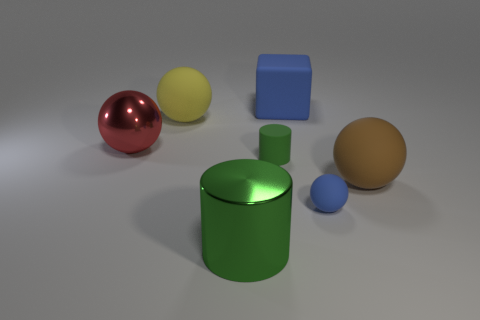There is a blue matte object that is in front of the metallic thing that is behind the metallic thing that is in front of the big shiny ball; how big is it?
Your answer should be compact. Small. How many other objects are the same color as the metallic cylinder?
Make the answer very short. 1. There is a tiny matte thing behind the big brown rubber ball; is it the same color as the shiny cylinder?
Your answer should be compact. Yes. There is a object that is the same color as the big cylinder; what size is it?
Your answer should be compact. Small. What number of things are rubber things that are right of the blue block or objects behind the big red shiny ball?
Your response must be concise. 4. Are there any red shiny balls that have the same size as the yellow sphere?
Provide a short and direct response. Yes. What is the color of the large metal thing that is the same shape as the small green rubber object?
Your response must be concise. Green. Is there a thing in front of the shiny object that is behind the blue sphere?
Provide a short and direct response. Yes. There is a blue rubber object that is in front of the brown thing; is it the same shape as the big red metallic thing?
Give a very brief answer. Yes. The large red metallic object has what shape?
Ensure brevity in your answer.  Sphere. 